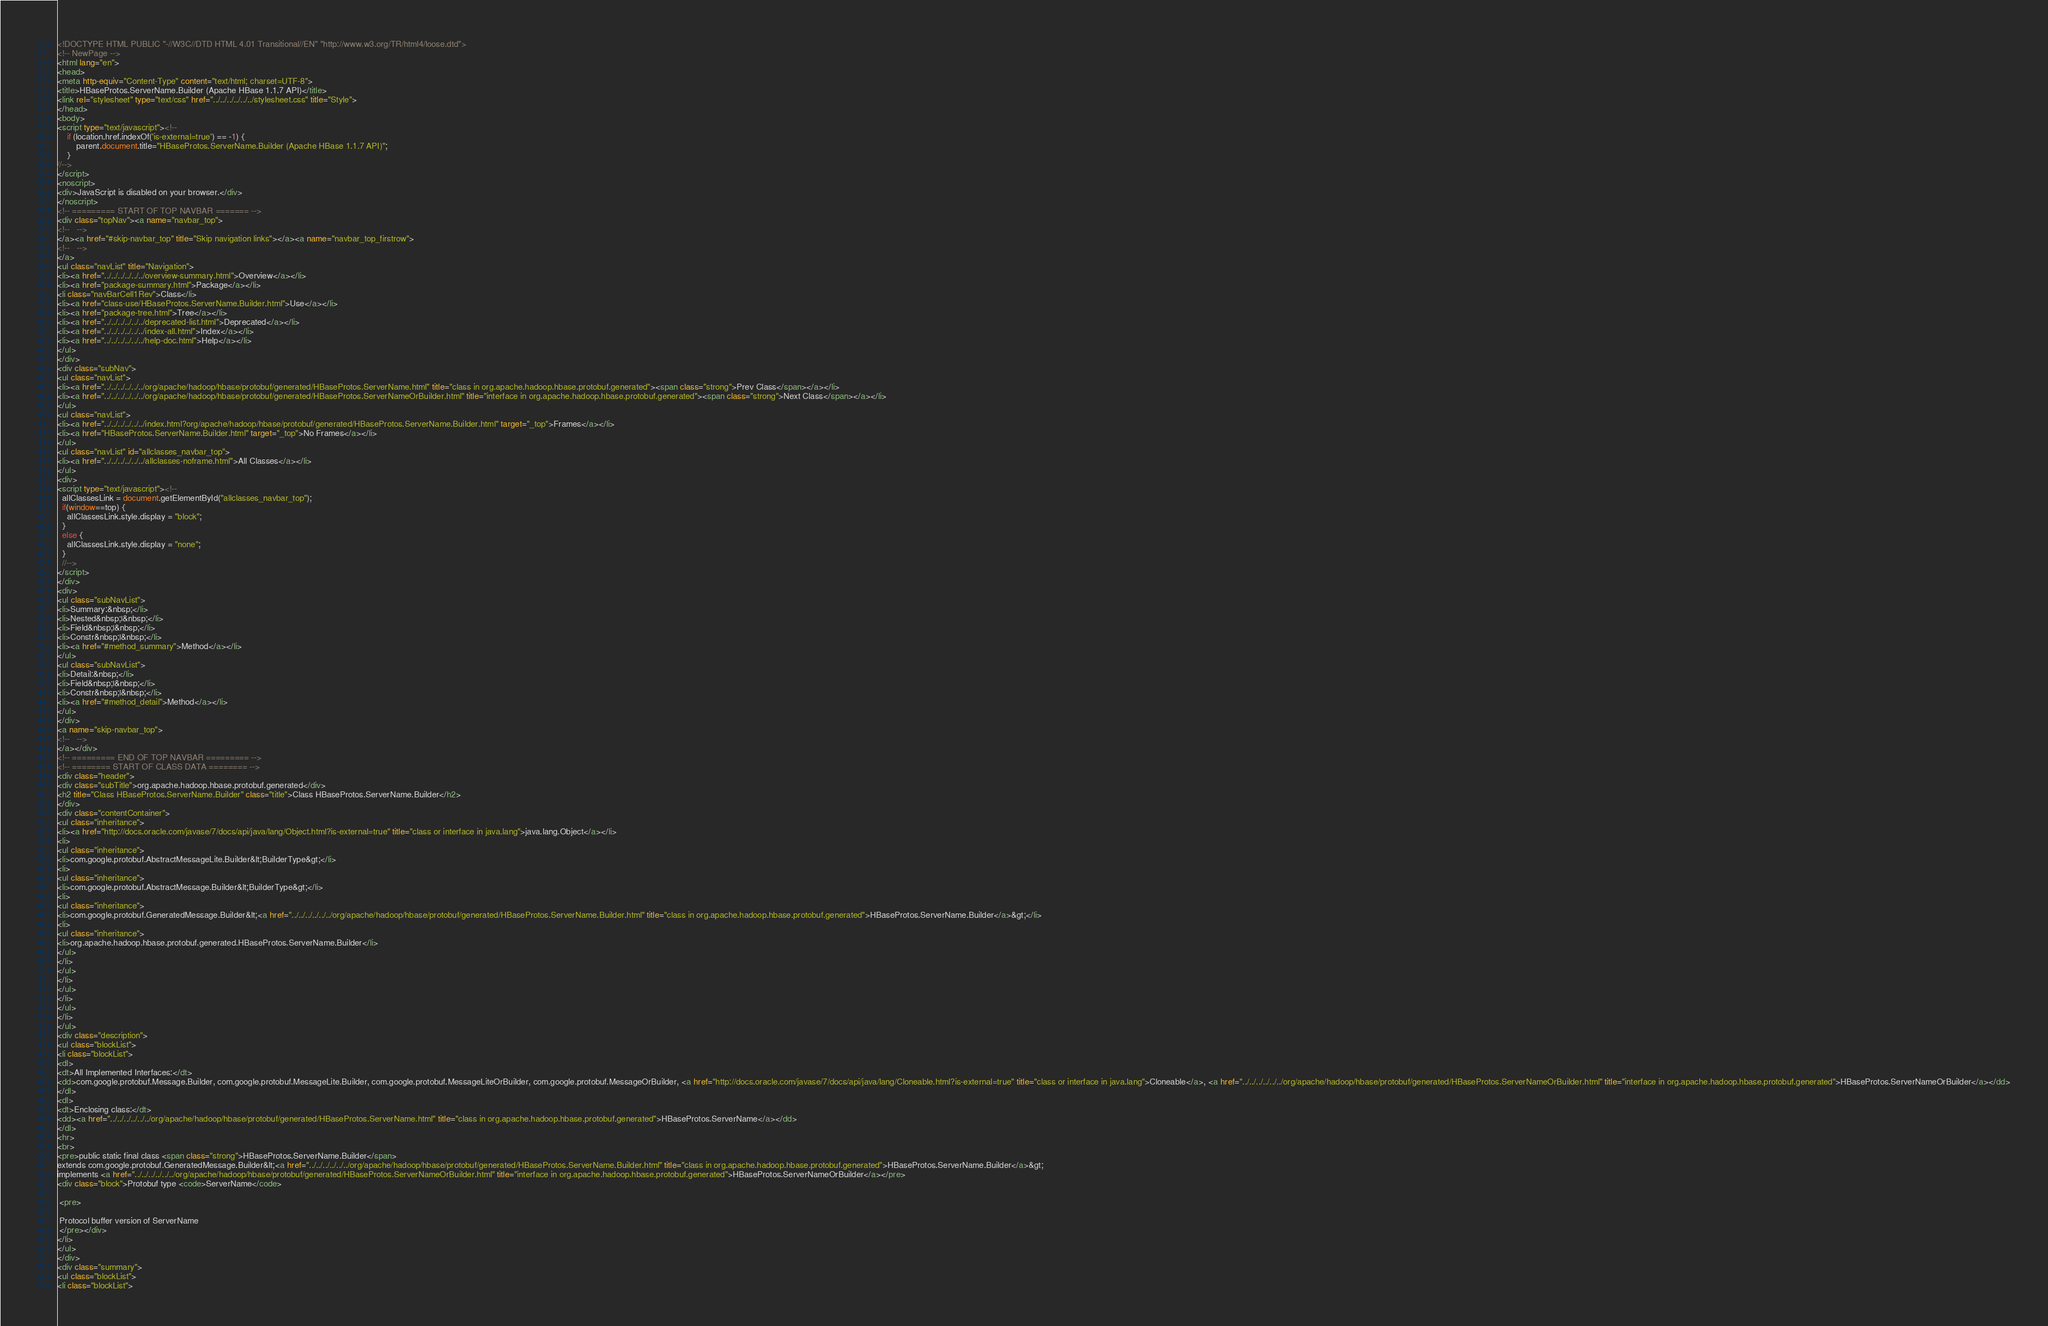<code> <loc_0><loc_0><loc_500><loc_500><_HTML_><!DOCTYPE HTML PUBLIC "-//W3C//DTD HTML 4.01 Transitional//EN" "http://www.w3.org/TR/html4/loose.dtd">
<!-- NewPage -->
<html lang="en">
<head>
<meta http-equiv="Content-Type" content="text/html; charset=UTF-8">
<title>HBaseProtos.ServerName.Builder (Apache HBase 1.1.7 API)</title>
<link rel="stylesheet" type="text/css" href="../../../../../../stylesheet.css" title="Style">
</head>
<body>
<script type="text/javascript"><!--
    if (location.href.indexOf('is-external=true') == -1) {
        parent.document.title="HBaseProtos.ServerName.Builder (Apache HBase 1.1.7 API)";
    }
//-->
</script>
<noscript>
<div>JavaScript is disabled on your browser.</div>
</noscript>
<!-- ========= START OF TOP NAVBAR ======= -->
<div class="topNav"><a name="navbar_top">
<!--   -->
</a><a href="#skip-navbar_top" title="Skip navigation links"></a><a name="navbar_top_firstrow">
<!--   -->
</a>
<ul class="navList" title="Navigation">
<li><a href="../../../../../../overview-summary.html">Overview</a></li>
<li><a href="package-summary.html">Package</a></li>
<li class="navBarCell1Rev">Class</li>
<li><a href="class-use/HBaseProtos.ServerName.Builder.html">Use</a></li>
<li><a href="package-tree.html">Tree</a></li>
<li><a href="../../../../../../deprecated-list.html">Deprecated</a></li>
<li><a href="../../../../../../index-all.html">Index</a></li>
<li><a href="../../../../../../help-doc.html">Help</a></li>
</ul>
</div>
<div class="subNav">
<ul class="navList">
<li><a href="../../../../../../org/apache/hadoop/hbase/protobuf/generated/HBaseProtos.ServerName.html" title="class in org.apache.hadoop.hbase.protobuf.generated"><span class="strong">Prev Class</span></a></li>
<li><a href="../../../../../../org/apache/hadoop/hbase/protobuf/generated/HBaseProtos.ServerNameOrBuilder.html" title="interface in org.apache.hadoop.hbase.protobuf.generated"><span class="strong">Next Class</span></a></li>
</ul>
<ul class="navList">
<li><a href="../../../../../../index.html?org/apache/hadoop/hbase/protobuf/generated/HBaseProtos.ServerName.Builder.html" target="_top">Frames</a></li>
<li><a href="HBaseProtos.ServerName.Builder.html" target="_top">No Frames</a></li>
</ul>
<ul class="navList" id="allclasses_navbar_top">
<li><a href="../../../../../../allclasses-noframe.html">All Classes</a></li>
</ul>
<div>
<script type="text/javascript"><!--
  allClassesLink = document.getElementById("allclasses_navbar_top");
  if(window==top) {
    allClassesLink.style.display = "block";
  }
  else {
    allClassesLink.style.display = "none";
  }
  //-->
</script>
</div>
<div>
<ul class="subNavList">
<li>Summary:&nbsp;</li>
<li>Nested&nbsp;|&nbsp;</li>
<li>Field&nbsp;|&nbsp;</li>
<li>Constr&nbsp;|&nbsp;</li>
<li><a href="#method_summary">Method</a></li>
</ul>
<ul class="subNavList">
<li>Detail:&nbsp;</li>
<li>Field&nbsp;|&nbsp;</li>
<li>Constr&nbsp;|&nbsp;</li>
<li><a href="#method_detail">Method</a></li>
</ul>
</div>
<a name="skip-navbar_top">
<!--   -->
</a></div>
<!-- ========= END OF TOP NAVBAR ========= -->
<!-- ======== START OF CLASS DATA ======== -->
<div class="header">
<div class="subTitle">org.apache.hadoop.hbase.protobuf.generated</div>
<h2 title="Class HBaseProtos.ServerName.Builder" class="title">Class HBaseProtos.ServerName.Builder</h2>
</div>
<div class="contentContainer">
<ul class="inheritance">
<li><a href="http://docs.oracle.com/javase/7/docs/api/java/lang/Object.html?is-external=true" title="class or interface in java.lang">java.lang.Object</a></li>
<li>
<ul class="inheritance">
<li>com.google.protobuf.AbstractMessageLite.Builder&lt;BuilderType&gt;</li>
<li>
<ul class="inheritance">
<li>com.google.protobuf.AbstractMessage.Builder&lt;BuilderType&gt;</li>
<li>
<ul class="inheritance">
<li>com.google.protobuf.GeneratedMessage.Builder&lt;<a href="../../../../../../org/apache/hadoop/hbase/protobuf/generated/HBaseProtos.ServerName.Builder.html" title="class in org.apache.hadoop.hbase.protobuf.generated">HBaseProtos.ServerName.Builder</a>&gt;</li>
<li>
<ul class="inheritance">
<li>org.apache.hadoop.hbase.protobuf.generated.HBaseProtos.ServerName.Builder</li>
</ul>
</li>
</ul>
</li>
</ul>
</li>
</ul>
</li>
</ul>
<div class="description">
<ul class="blockList">
<li class="blockList">
<dl>
<dt>All Implemented Interfaces:</dt>
<dd>com.google.protobuf.Message.Builder, com.google.protobuf.MessageLite.Builder, com.google.protobuf.MessageLiteOrBuilder, com.google.protobuf.MessageOrBuilder, <a href="http://docs.oracle.com/javase/7/docs/api/java/lang/Cloneable.html?is-external=true" title="class or interface in java.lang">Cloneable</a>, <a href="../../../../../../org/apache/hadoop/hbase/protobuf/generated/HBaseProtos.ServerNameOrBuilder.html" title="interface in org.apache.hadoop.hbase.protobuf.generated">HBaseProtos.ServerNameOrBuilder</a></dd>
</dl>
<dl>
<dt>Enclosing class:</dt>
<dd><a href="../../../../../../org/apache/hadoop/hbase/protobuf/generated/HBaseProtos.ServerName.html" title="class in org.apache.hadoop.hbase.protobuf.generated">HBaseProtos.ServerName</a></dd>
</dl>
<hr>
<br>
<pre>public static final class <span class="strong">HBaseProtos.ServerName.Builder</span>
extends com.google.protobuf.GeneratedMessage.Builder&lt;<a href="../../../../../../org/apache/hadoop/hbase/protobuf/generated/HBaseProtos.ServerName.Builder.html" title="class in org.apache.hadoop.hbase.protobuf.generated">HBaseProtos.ServerName.Builder</a>&gt;
implements <a href="../../../../../../org/apache/hadoop/hbase/protobuf/generated/HBaseProtos.ServerNameOrBuilder.html" title="interface in org.apache.hadoop.hbase.protobuf.generated">HBaseProtos.ServerNameOrBuilder</a></pre>
<div class="block">Protobuf type <code>ServerName</code>

 <pre>

 Protocol buffer version of ServerName
 </pre></div>
</li>
</ul>
</div>
<div class="summary">
<ul class="blockList">
<li class="blockList"></code> 